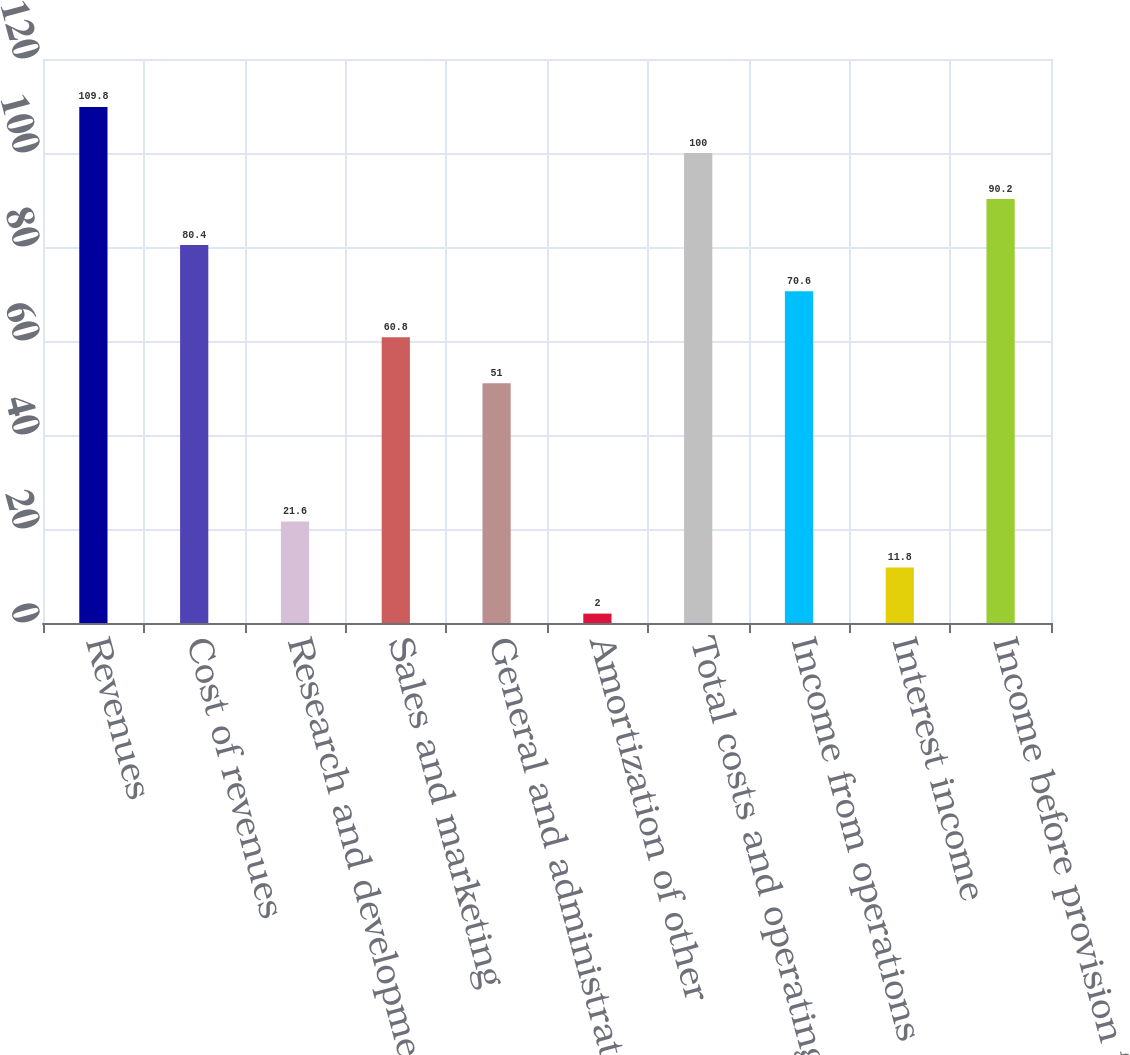Convert chart to OTSL. <chart><loc_0><loc_0><loc_500><loc_500><bar_chart><fcel>Revenues<fcel>Cost of revenues<fcel>Research and development<fcel>Sales and marketing<fcel>General and administrative<fcel>Amortization of other<fcel>Total costs and operating<fcel>Income from operations<fcel>Interest income<fcel>Income before provision for<nl><fcel>109.8<fcel>80.4<fcel>21.6<fcel>60.8<fcel>51<fcel>2<fcel>100<fcel>70.6<fcel>11.8<fcel>90.2<nl></chart> 